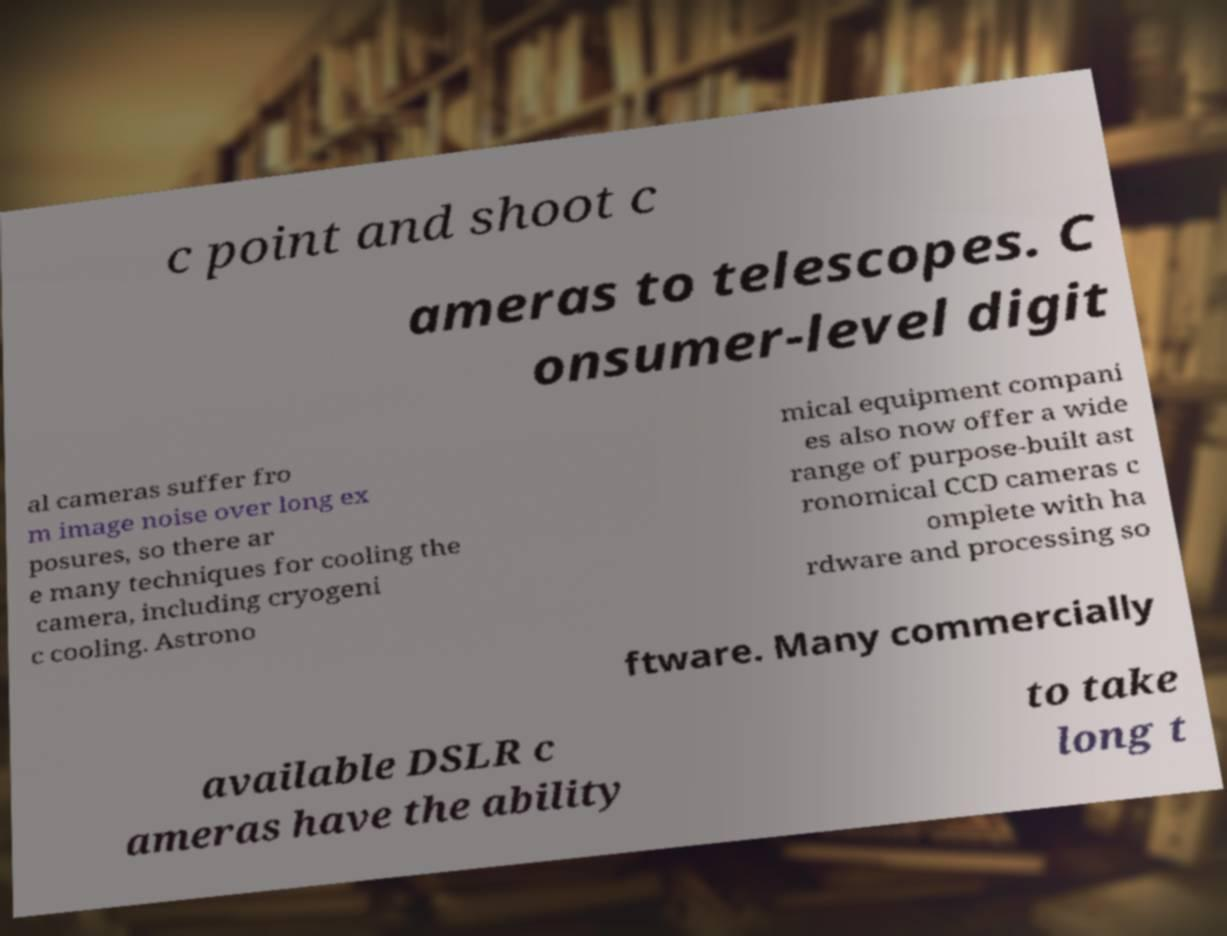For documentation purposes, I need the text within this image transcribed. Could you provide that? c point and shoot c ameras to telescopes. C onsumer-level digit al cameras suffer fro m image noise over long ex posures, so there ar e many techniques for cooling the camera, including cryogeni c cooling. Astrono mical equipment compani es also now offer a wide range of purpose-built ast ronomical CCD cameras c omplete with ha rdware and processing so ftware. Many commercially available DSLR c ameras have the ability to take long t 